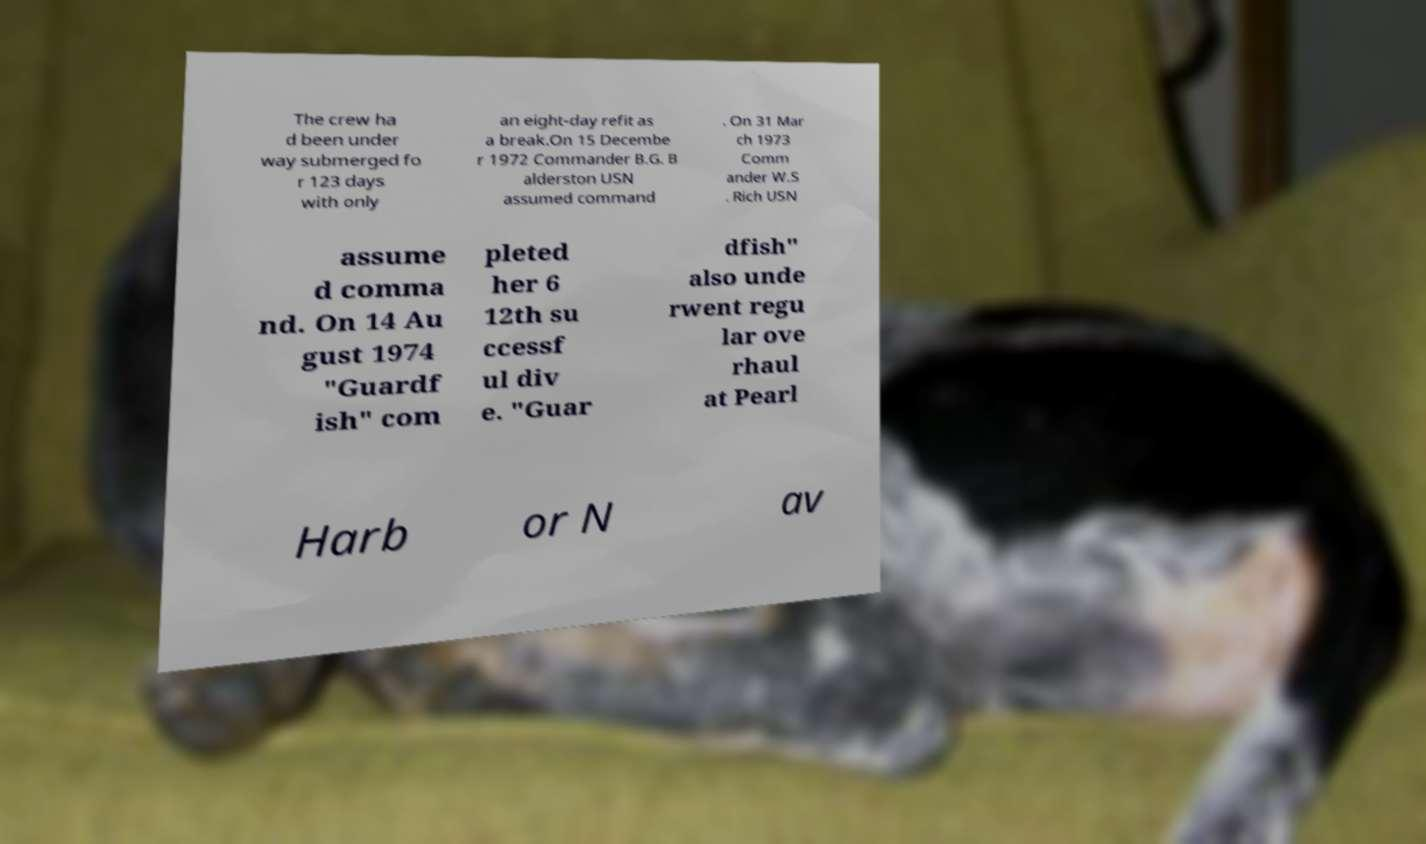I need the written content from this picture converted into text. Can you do that? The crew ha d been under way submerged fo r 123 days with only an eight-day refit as a break.On 15 Decembe r 1972 Commander B.G. B alderston USN assumed command . On 31 Mar ch 1973 Comm ander W.S . Rich USN assume d comma nd. On 14 Au gust 1974 "Guardf ish" com pleted her 6 12th su ccessf ul div e. "Guar dfish" also unde rwent regu lar ove rhaul at Pearl Harb or N av 